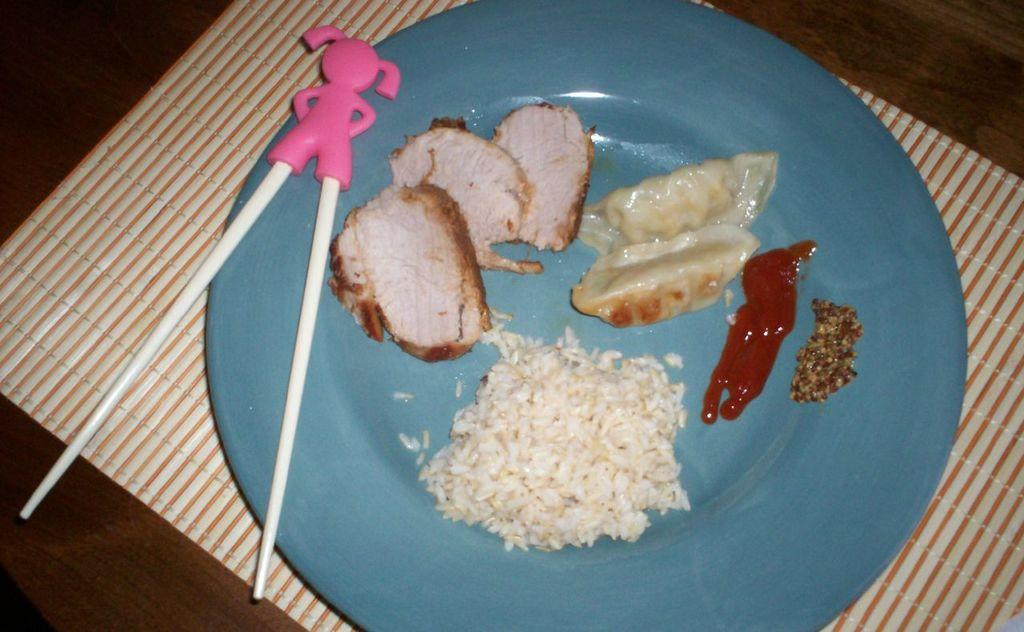What type of furniture is present in the image? There is a table in the image. What is covering the table? There is a cloth on the table. What is placed on the cloth? There is a plate on the cloth. What is on the plate? There is a food item on the plate. What utensil is placed with the food item? There are chopsticks on the plate. What type of account is being discussed in the image? There is no mention of an account in the image; it features a table with a cloth, plate, food item, and chopsticks. Can you see a snail crawling on the table in the image? No, there is no snail present in the image. 